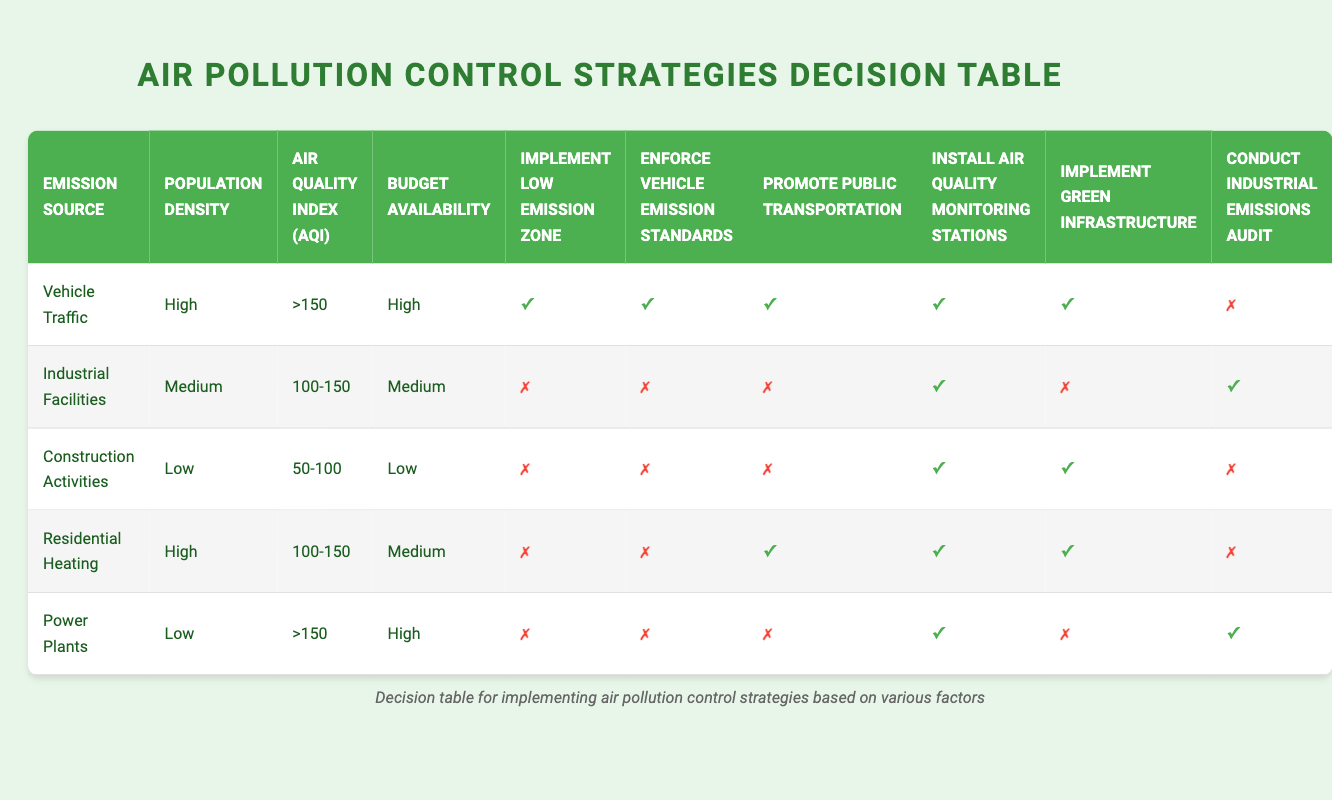What strategies are suggested for high population density with vehicle traffic and an AQI greater than 150? According to the table, for "Vehicle Traffic" with "High" population density and an AQI of ">150", all strategies (Implement Low Emission Zone, Enforce Vehicle Emission Standards, Promote Public Transportation, Install Air Quality Monitoring Stations, Implement Green Infrastructure) are suggested as they are marked true.
Answer: All strategies Is it recommended to promote public transportation for industrial facilities with a medium population density and AQI between 100 and 150? The table shows that for "Industrial Facilities" with "Medium" population density and an AQI of "100-150", promoting public transportation is marked as false, indicating it is not recommended.
Answer: No Which emission source has the highest number of recommended strategies? When looking at the row for "Vehicle Traffic", it has 5 strategies recommended (all marked true), while others have fewer or none. Thus, it has the highest number of recommended strategies.
Answer: Vehicle Traffic For low-budget scenarios, which emission source suggests installing air quality monitoring stations? The table shows that both "Construction Activities" and "Power Plants" have "Low" budget availability and recommend installing air quality monitoring stations (both marked true).
Answer: Construction Activities and Power Plants Is it true that residential heating with a medium population density and AQI of 100-150 has any strategy suggesting to enforce vehicle emission standards? The table indicates that for "Residential Heating" under those conditions, it is marked as false for enforcing vehicle emission standards, confirming it is not recommended.
Answer: No How many strategies proposed for industrial facilities are true compared to those for power plants? For "Industrial Facilities," 2 strategies are true (Install Air Quality Monitoring Stations, Conduct Industrial Emissions Audit), and for "Power Plants," 2 strategies are true as well (Install Air Quality Monitoring Stations, Conduct Industrial Emissions Audit). Hence, the count is equal.
Answer: Equal What is the average number of true strategies across all emission sources in the table? By counting true strategies: Vehicle Traffic (5), Industrial Facilities (2), Construction Activities (2), Residential Heating (3), Power Plants (2). The total is 14 true strategies across 5 sources, which gives an average of 14/5 = 2.8.
Answer: 2.8 Which emission source requires a higher budget: vehicle traffic or residential heating? The table indicates that "Vehicle Traffic" has a "High" budget, whereas "Residential Heating" has a "Medium" budget. Therefore, vehicle traffic requires a higher budget.
Answer: Vehicle Traffic 